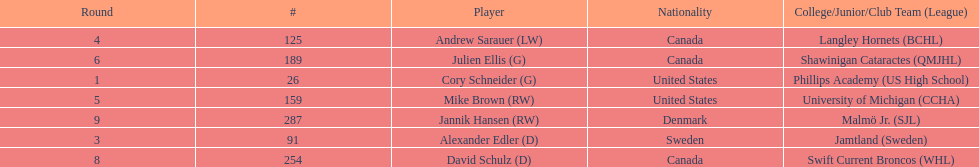What number of players have canada listed as their nationality? 3. 